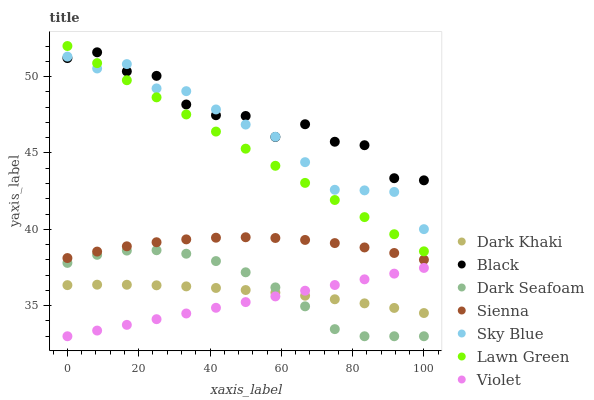Does Violet have the minimum area under the curve?
Answer yes or no. Yes. Does Black have the maximum area under the curve?
Answer yes or no. Yes. Does Lawn Green have the minimum area under the curve?
Answer yes or no. No. Does Lawn Green have the maximum area under the curve?
Answer yes or no. No. Is Violet the smoothest?
Answer yes or no. Yes. Is Black the roughest?
Answer yes or no. Yes. Is Lawn Green the smoothest?
Answer yes or no. No. Is Lawn Green the roughest?
Answer yes or no. No. Does Dark Seafoam have the lowest value?
Answer yes or no. Yes. Does Lawn Green have the lowest value?
Answer yes or no. No. Does Lawn Green have the highest value?
Answer yes or no. Yes. Does Dark Khaki have the highest value?
Answer yes or no. No. Is Dark Seafoam less than Lawn Green?
Answer yes or no. Yes. Is Black greater than Dark Seafoam?
Answer yes or no. Yes. Does Violet intersect Dark Khaki?
Answer yes or no. Yes. Is Violet less than Dark Khaki?
Answer yes or no. No. Is Violet greater than Dark Khaki?
Answer yes or no. No. Does Dark Seafoam intersect Lawn Green?
Answer yes or no. No. 